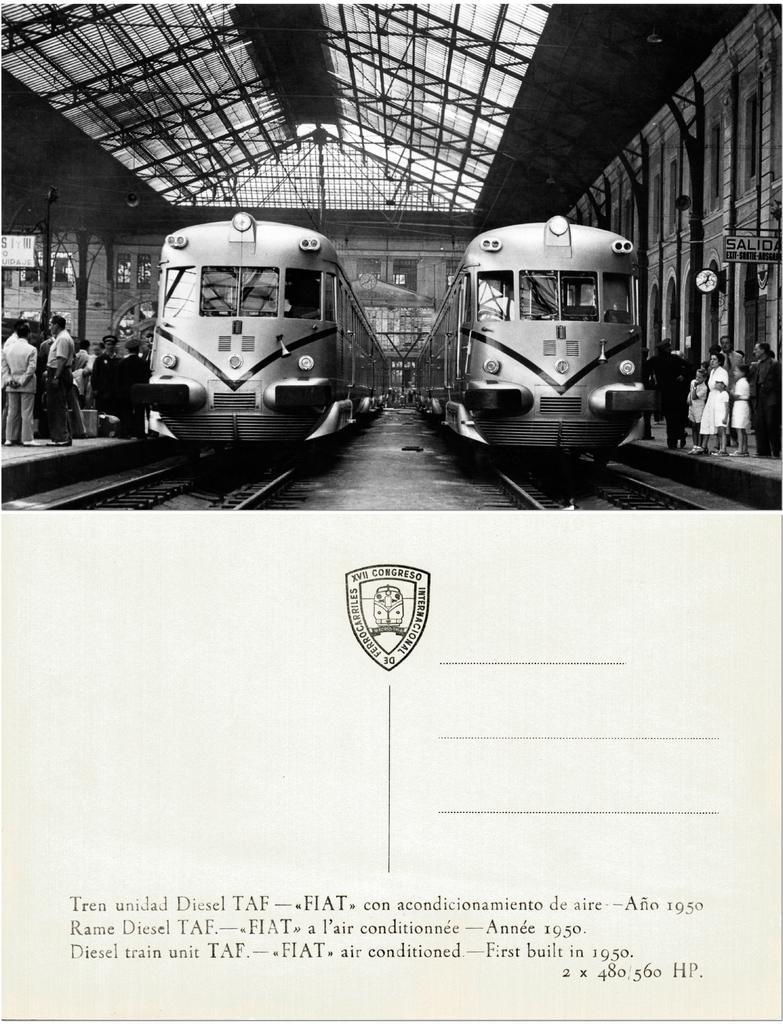Describe this image in one or two sentences. In the picture we can see a card with a photograph of two trains on the tracks and besides it we can see people are standing on the platforms under the station and under the photograph we can see a logo and under it we can see some information. 